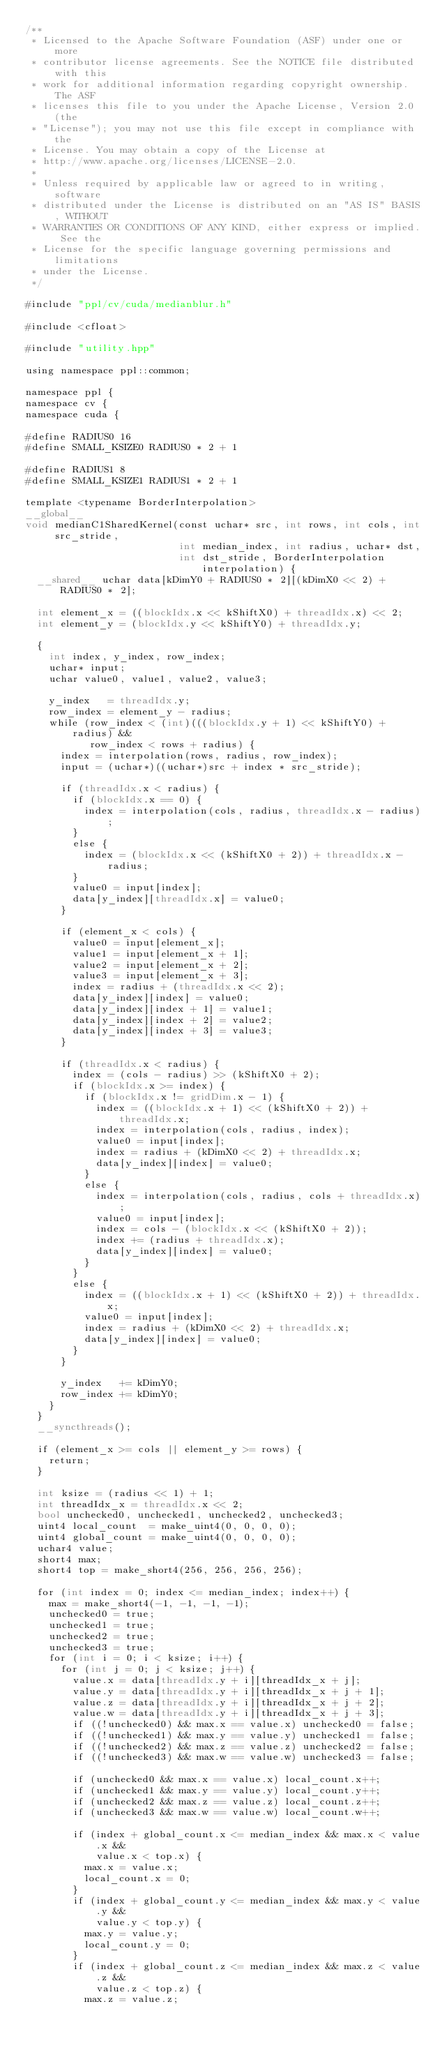<code> <loc_0><loc_0><loc_500><loc_500><_Cuda_>/**
 * Licensed to the Apache Software Foundation (ASF) under one or more
 * contributor license agreements. See the NOTICE file distributed with this
 * work for additional information regarding copyright ownership. The ASF
 * licenses this file to you under the Apache License, Version 2.0 (the
 * "License"); you may not use this file except in compliance with the
 * License. You may obtain a copy of the License at
 * http://www.apache.org/licenses/LICENSE-2.0.
 *
 * Unless required by applicable law or agreed to in writing, software
 * distributed under the License is distributed on an "AS IS" BASIS, WITHOUT
 * WARRANTIES OR CONDITIONS OF ANY KIND, either express or implied. See the
 * License for the specific language governing permissions and limitations
 * under the License.
 */

#include "ppl/cv/cuda/medianblur.h"

#include <cfloat>

#include "utility.hpp"

using namespace ppl::common;

namespace ppl {
namespace cv {
namespace cuda {

#define RADIUS0 16
#define SMALL_KSIZE0 RADIUS0 * 2 + 1

#define RADIUS1 8
#define SMALL_KSIZE1 RADIUS1 * 2 + 1

template <typename BorderInterpolation>
__global__
void medianC1SharedKernel(const uchar* src, int rows, int cols, int src_stride,
                          int median_index, int radius, uchar* dst,
                          int dst_stride, BorderInterpolation interpolation) {
  __shared__ uchar data[kDimY0 + RADIUS0 * 2][(kDimX0 << 2) + RADIUS0 * 2];

  int element_x = ((blockIdx.x << kShiftX0) + threadIdx.x) << 2;
  int element_y = (blockIdx.y << kShiftY0) + threadIdx.y;

  {
    int index, y_index, row_index;
    uchar* input;
    uchar value0, value1, value2, value3;

    y_index   = threadIdx.y;
    row_index = element_y - radius;
    while (row_index < (int)(((blockIdx.y + 1) << kShiftY0) + radius) &&
           row_index < rows + radius) {
      index = interpolation(rows, radius, row_index);
      input = (uchar*)((uchar*)src + index * src_stride);

      if (threadIdx.x < radius) {
        if (blockIdx.x == 0) {
          index = interpolation(cols, radius, threadIdx.x - radius);
        }
        else {
          index = (blockIdx.x << (kShiftX0 + 2)) + threadIdx.x - radius;
        }
        value0 = input[index];
        data[y_index][threadIdx.x] = value0;
      }

      if (element_x < cols) {
        value0 = input[element_x];
        value1 = input[element_x + 1];
        value2 = input[element_x + 2];
        value3 = input[element_x + 3];
        index = radius + (threadIdx.x << 2);
        data[y_index][index] = value0;
        data[y_index][index + 1] = value1;
        data[y_index][index + 2] = value2;
        data[y_index][index + 3] = value3;
      }

      if (threadIdx.x < radius) {
        index = (cols - radius) >> (kShiftX0 + 2);
        if (blockIdx.x >= index) {
          if (blockIdx.x != gridDim.x - 1) {
            index = ((blockIdx.x + 1) << (kShiftX0 + 2)) + threadIdx.x;
            index = interpolation(cols, radius, index);
            value0 = input[index];
            index = radius + (kDimX0 << 2) + threadIdx.x;
            data[y_index][index] = value0;
          }
          else {
            index = interpolation(cols, radius, cols + threadIdx.x);
            value0 = input[index];
            index = cols - (blockIdx.x << (kShiftX0 + 2));
            index += (radius + threadIdx.x);
            data[y_index][index] = value0;
          }
        }
        else {
          index = ((blockIdx.x + 1) << (kShiftX0 + 2)) + threadIdx.x;
          value0 = input[index];
          index = radius + (kDimX0 << 2) + threadIdx.x;
          data[y_index][index] = value0;
        }
      }

      y_index   += kDimY0;
      row_index += kDimY0;
    }
  }
  __syncthreads();

  if (element_x >= cols || element_y >= rows) {
    return;
  }

  int ksize = (radius << 1) + 1;
  int threadIdx_x = threadIdx.x << 2;
  bool unchecked0, unchecked1, unchecked2, unchecked3;
  uint4 local_count  = make_uint4(0, 0, 0, 0);
  uint4 global_count = make_uint4(0, 0, 0, 0);
  uchar4 value;
  short4 max;
  short4 top = make_short4(256, 256, 256, 256);

  for (int index = 0; index <= median_index; index++) {
    max = make_short4(-1, -1, -1, -1);
    unchecked0 = true;
    unchecked1 = true;
    unchecked2 = true;
    unchecked3 = true;
    for (int i = 0; i < ksize; i++) {
      for (int j = 0; j < ksize; j++) {
        value.x = data[threadIdx.y + i][threadIdx_x + j];
        value.y = data[threadIdx.y + i][threadIdx_x + j + 1];
        value.z = data[threadIdx.y + i][threadIdx_x + j + 2];
        value.w = data[threadIdx.y + i][threadIdx_x + j + 3];
        if ((!unchecked0) && max.x == value.x) unchecked0 = false;
        if ((!unchecked1) && max.y == value.y) unchecked1 = false;
        if ((!unchecked2) && max.z == value.z) unchecked2 = false;
        if ((!unchecked3) && max.w == value.w) unchecked3 = false;

        if (unchecked0 && max.x == value.x) local_count.x++;
        if (unchecked1 && max.y == value.y) local_count.y++;
        if (unchecked2 && max.z == value.z) local_count.z++;
        if (unchecked3 && max.w == value.w) local_count.w++;

        if (index + global_count.x <= median_index && max.x < value.x &&
            value.x < top.x) {
          max.x = value.x;
          local_count.x = 0;
        }
        if (index + global_count.y <= median_index && max.y < value.y &&
            value.y < top.y) {
          max.y = value.y;
          local_count.y = 0;
        }
        if (index + global_count.z <= median_index && max.z < value.z &&
            value.z < top.z) {
          max.z = value.z;</code> 